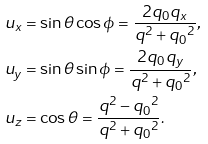Convert formula to latex. <formula><loc_0><loc_0><loc_500><loc_500>u _ { x } & = \sin \theta \cos \phi = \frac { 2 q _ { 0 } q _ { x } } { q ^ { 2 } + { q _ { 0 } } ^ { 2 } } , \\ u _ { y } & = \sin \theta \sin \phi = \frac { 2 q _ { 0 } q _ { y } } { q ^ { 2 } + { q _ { 0 } } ^ { 2 } } , \\ u _ { z } & = \cos \theta = \frac { q ^ { 2 } - { q _ { 0 } } ^ { 2 } } { q ^ { 2 } + { q _ { 0 } } ^ { 2 } } .</formula> 